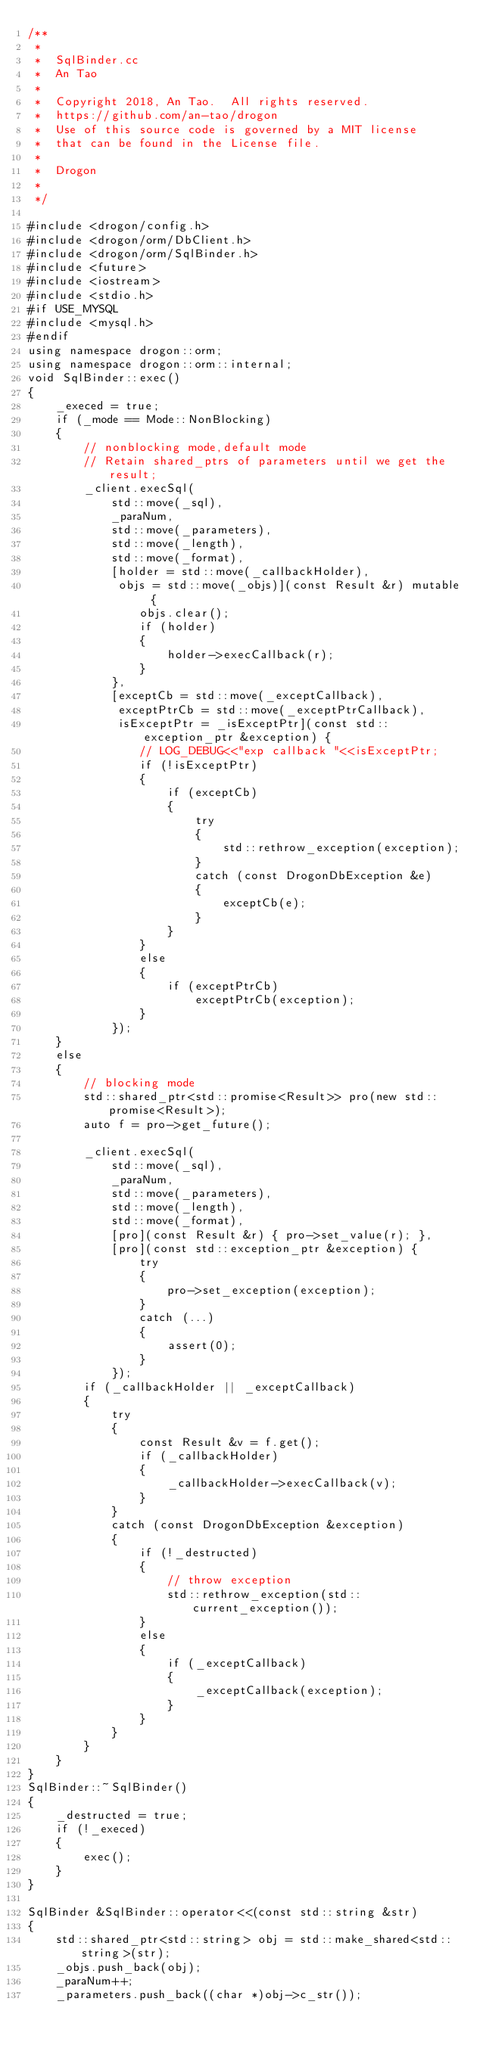Convert code to text. <code><loc_0><loc_0><loc_500><loc_500><_C++_>/**
 *
 *  SqlBinder.cc
 *  An Tao
 *
 *  Copyright 2018, An Tao.  All rights reserved.
 *  https://github.com/an-tao/drogon
 *  Use of this source code is governed by a MIT license
 *  that can be found in the License file.
 *
 *  Drogon
 *
 */

#include <drogon/config.h>
#include <drogon/orm/DbClient.h>
#include <drogon/orm/SqlBinder.h>
#include <future>
#include <iostream>
#include <stdio.h>
#if USE_MYSQL
#include <mysql.h>
#endif
using namespace drogon::orm;
using namespace drogon::orm::internal;
void SqlBinder::exec()
{
    _execed = true;
    if (_mode == Mode::NonBlocking)
    {
        // nonblocking mode,default mode
        // Retain shared_ptrs of parameters until we get the result;
        _client.execSql(
            std::move(_sql),
            _paraNum,
            std::move(_parameters),
            std::move(_length),
            std::move(_format),
            [holder = std::move(_callbackHolder),
             objs = std::move(_objs)](const Result &r) mutable {
                objs.clear();
                if (holder)
                {
                    holder->execCallback(r);
                }
            },
            [exceptCb = std::move(_exceptCallback),
             exceptPtrCb = std::move(_exceptPtrCallback),
             isExceptPtr = _isExceptPtr](const std::exception_ptr &exception) {
                // LOG_DEBUG<<"exp callback "<<isExceptPtr;
                if (!isExceptPtr)
                {
                    if (exceptCb)
                    {
                        try
                        {
                            std::rethrow_exception(exception);
                        }
                        catch (const DrogonDbException &e)
                        {
                            exceptCb(e);
                        }
                    }
                }
                else
                {
                    if (exceptPtrCb)
                        exceptPtrCb(exception);
                }
            });
    }
    else
    {
        // blocking mode
        std::shared_ptr<std::promise<Result>> pro(new std::promise<Result>);
        auto f = pro->get_future();

        _client.execSql(
            std::move(_sql),
            _paraNum,
            std::move(_parameters),
            std::move(_length),
            std::move(_format),
            [pro](const Result &r) { pro->set_value(r); },
            [pro](const std::exception_ptr &exception) {
                try
                {
                    pro->set_exception(exception);
                }
                catch (...)
                {
                    assert(0);
                }
            });
        if (_callbackHolder || _exceptCallback)
        {
            try
            {
                const Result &v = f.get();
                if (_callbackHolder)
                {
                    _callbackHolder->execCallback(v);
                }
            }
            catch (const DrogonDbException &exception)
            {
                if (!_destructed)
                {
                    // throw exception
                    std::rethrow_exception(std::current_exception());
                }
                else
                {
                    if (_exceptCallback)
                    {
                        _exceptCallback(exception);
                    }
                }
            }
        }
    }
}
SqlBinder::~SqlBinder()
{
    _destructed = true;
    if (!_execed)
    {
        exec();
    }
}

SqlBinder &SqlBinder::operator<<(const std::string &str)
{
    std::shared_ptr<std::string> obj = std::make_shared<std::string>(str);
    _objs.push_back(obj);
    _paraNum++;
    _parameters.push_back((char *)obj->c_str());</code> 